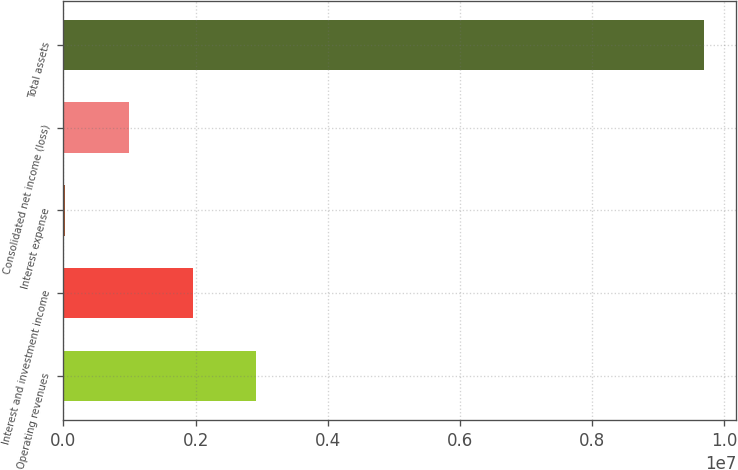<chart> <loc_0><loc_0><loc_500><loc_500><bar_chart><fcel>Operating revenues<fcel>Interest and investment income<fcel>Interest expense<fcel>Consolidated net income (loss)<fcel>Total assets<nl><fcel>2.92044e+06<fcel>1.9524e+06<fcel>16323<fcel>984361<fcel>9.6967e+06<nl></chart> 